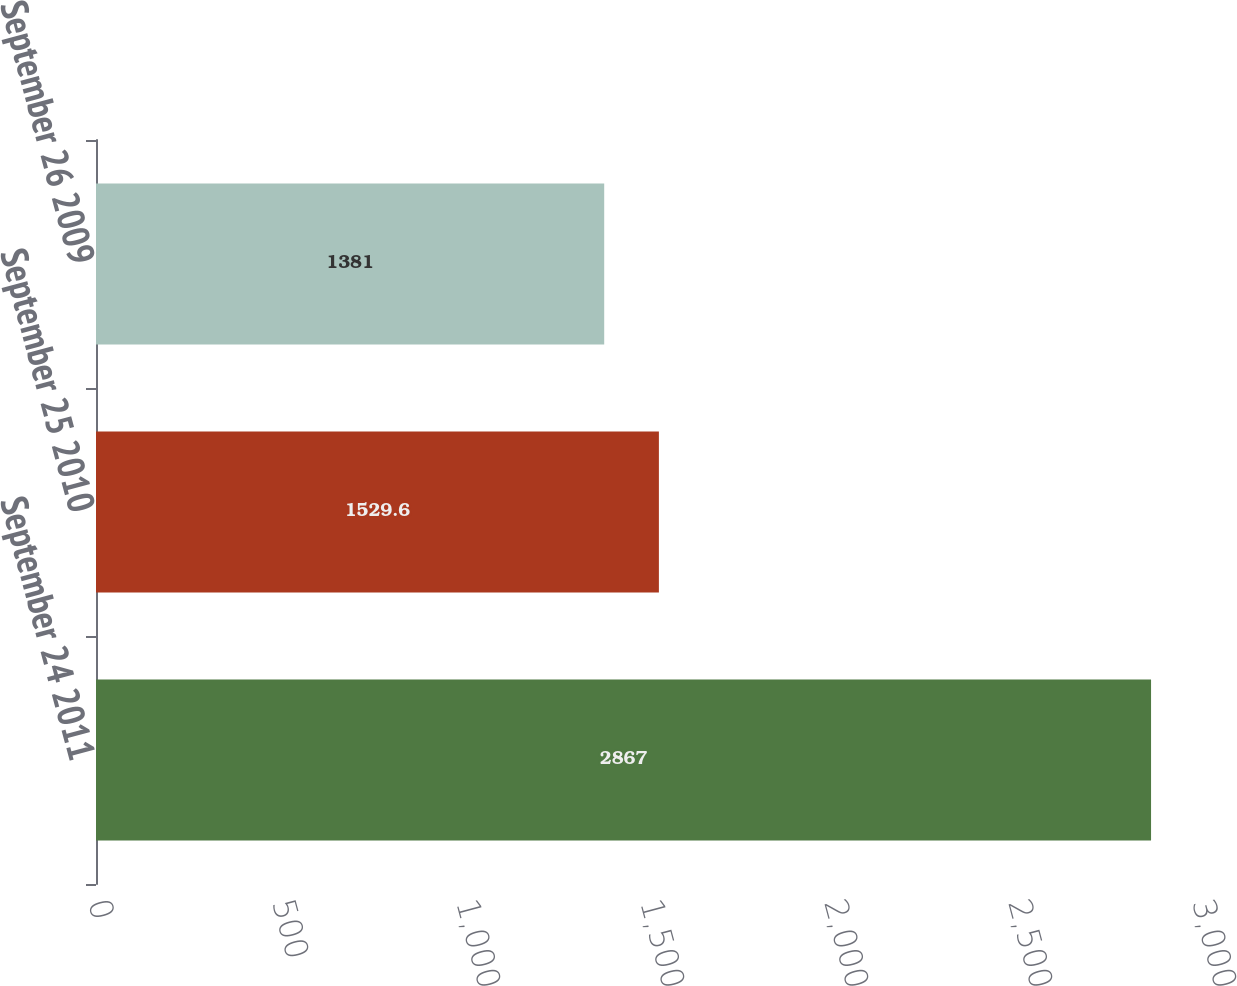Convert chart to OTSL. <chart><loc_0><loc_0><loc_500><loc_500><bar_chart><fcel>September 24 2011<fcel>September 25 2010<fcel>September 26 2009<nl><fcel>2867<fcel>1529.6<fcel>1381<nl></chart> 